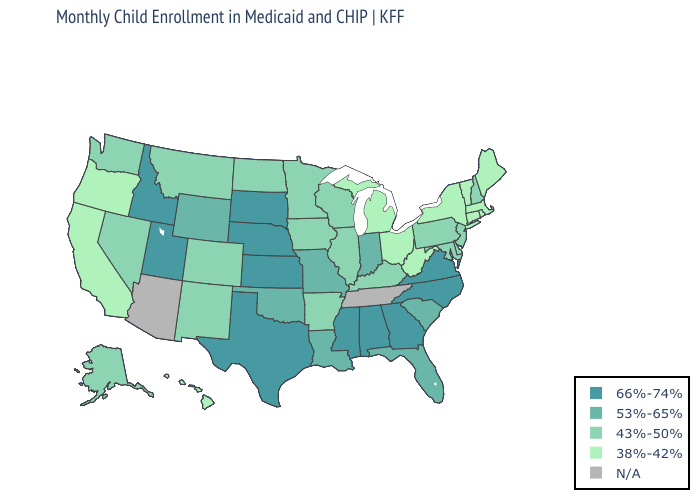Does the first symbol in the legend represent the smallest category?
Keep it brief. No. What is the value of North Dakota?
Quick response, please. 43%-50%. What is the value of California?
Concise answer only. 38%-42%. Name the states that have a value in the range 53%-65%?
Write a very short answer. Florida, Indiana, Louisiana, Missouri, Oklahoma, South Carolina, Wyoming. Among the states that border Vermont , does New Hampshire have the lowest value?
Answer briefly. No. Does Maine have the lowest value in the Northeast?
Answer briefly. Yes. Among the states that border Kentucky , which have the lowest value?
Be succinct. Ohio, West Virginia. What is the value of Mississippi?
Be succinct. 66%-74%. Among the states that border Oklahoma , does Kansas have the lowest value?
Quick response, please. No. Name the states that have a value in the range 38%-42%?
Answer briefly. California, Connecticut, Hawaii, Maine, Massachusetts, Michigan, New York, Ohio, Oregon, Rhode Island, Vermont, West Virginia. What is the value of Kansas?
Concise answer only. 66%-74%. Among the states that border Georgia , does South Carolina have the lowest value?
Write a very short answer. Yes. What is the highest value in states that border New Jersey?
Short answer required. 43%-50%. What is the highest value in the USA?
Answer briefly. 66%-74%. 